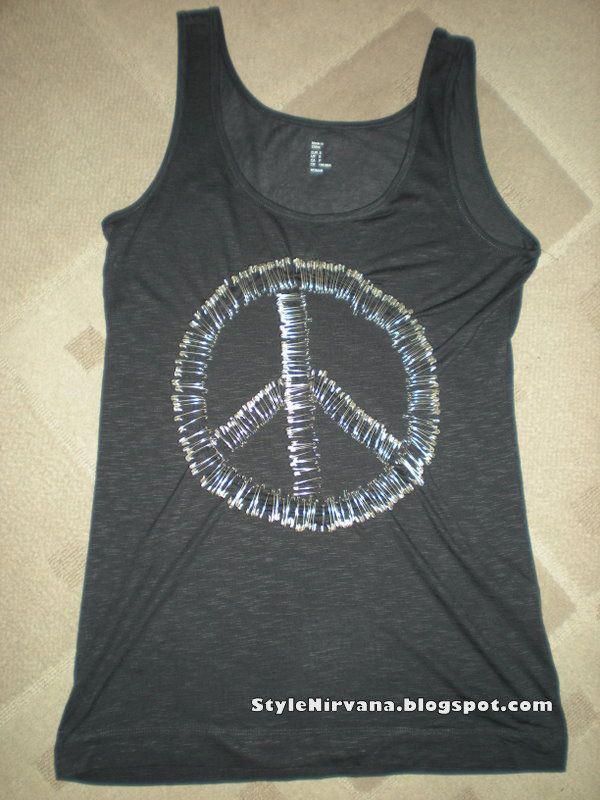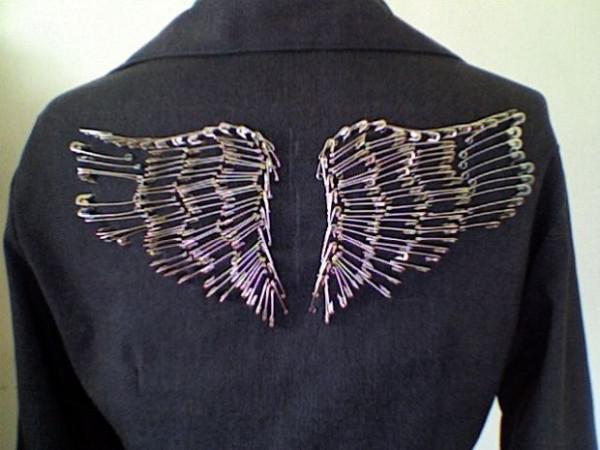The first image is the image on the left, the second image is the image on the right. Examine the images to the left and right. Is the description "there is a black top with the peace sihn made from bobby pins" accurate? Answer yes or no. Yes. The first image is the image on the left, the second image is the image on the right. Analyze the images presented: Is the assertion "There is a black shirt with a peace sign on it and a black collared jacket." valid? Answer yes or no. Yes. 